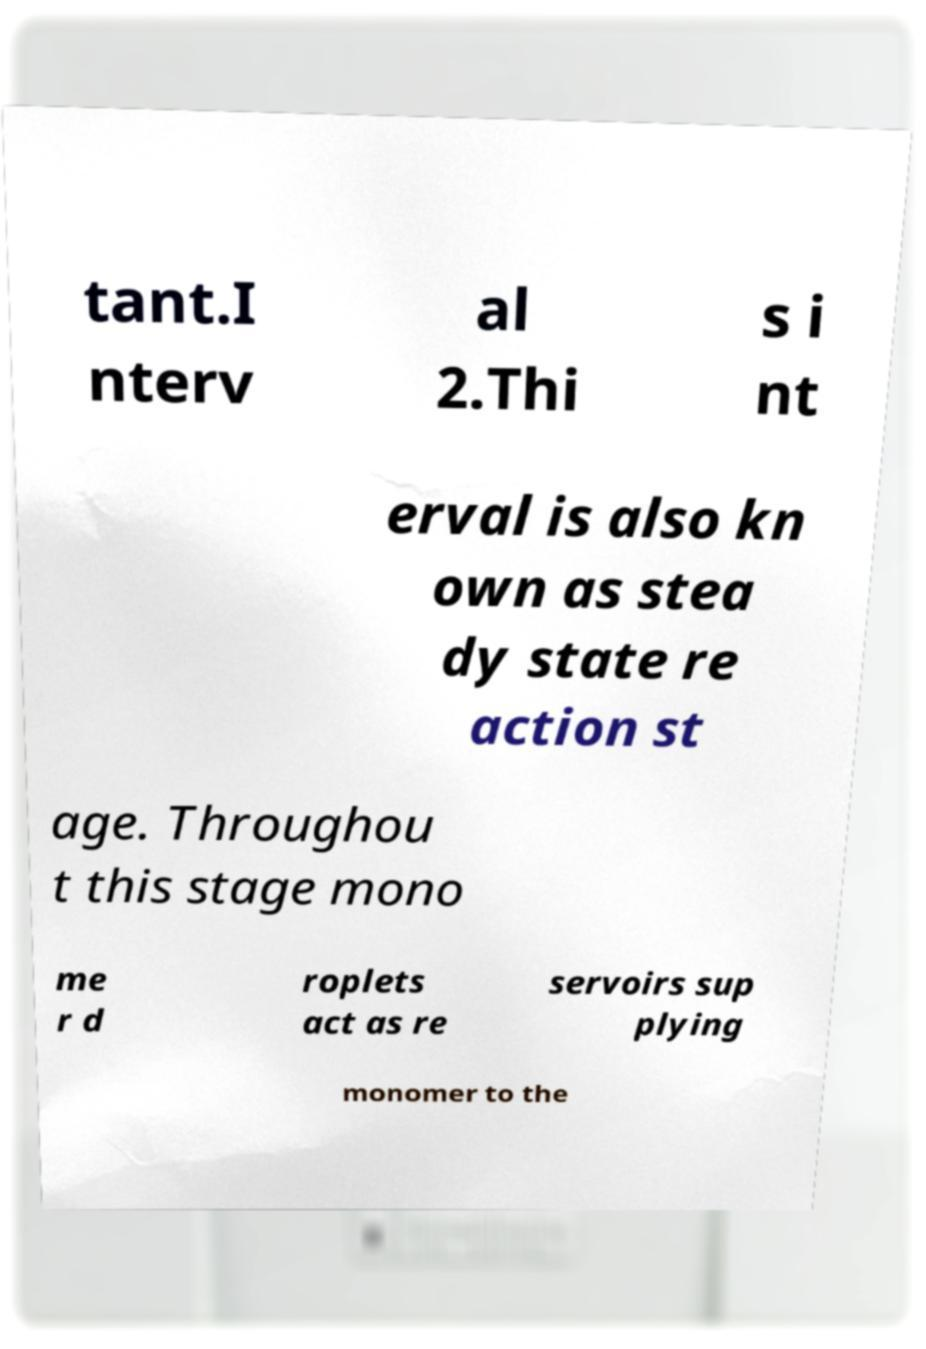Please read and relay the text visible in this image. What does it say? tant.I nterv al 2.Thi s i nt erval is also kn own as stea dy state re action st age. Throughou t this stage mono me r d roplets act as re servoirs sup plying monomer to the 